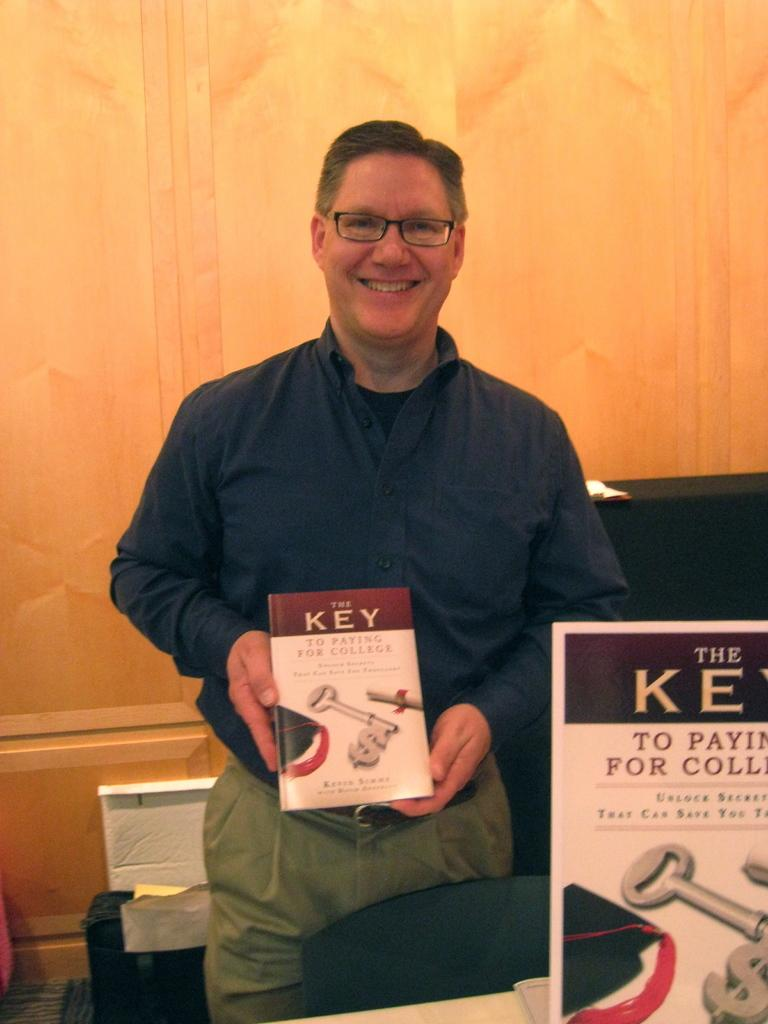Provide a one-sentence caption for the provided image. A man holding up a book titled "The Key To Paying For College.". 